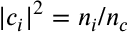<formula> <loc_0><loc_0><loc_500><loc_500>| c _ { i } | ^ { 2 } = n _ { i } / n _ { c }</formula> 